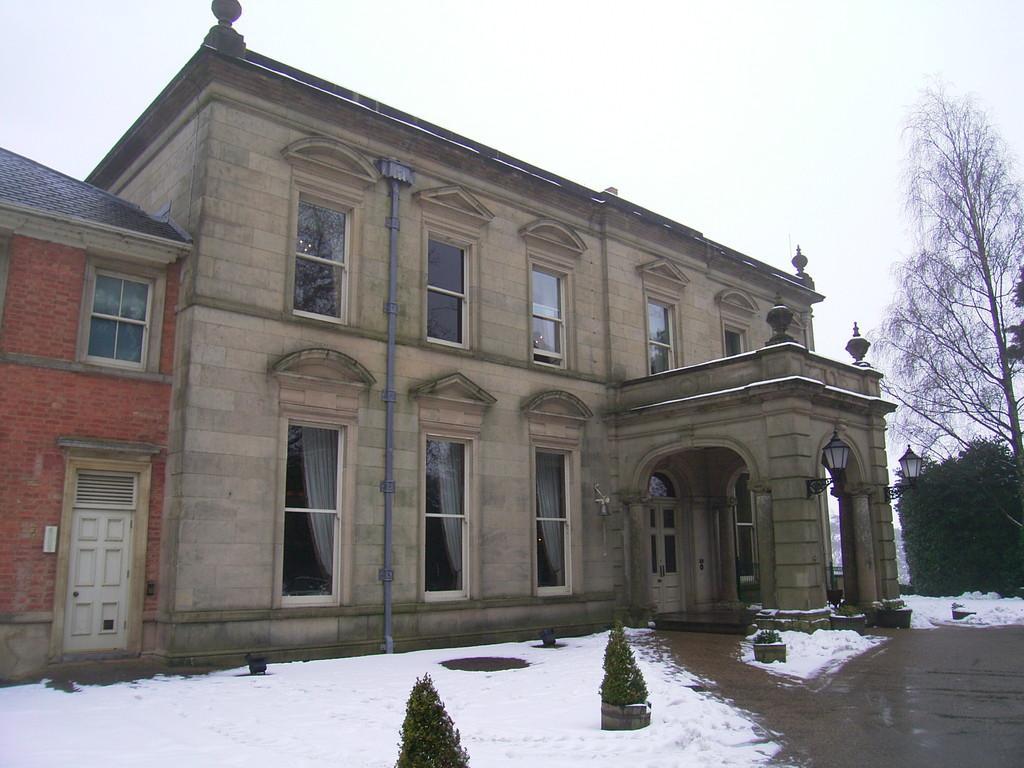Describe this image in one or two sentences. In the image there is a building in the back with many windows and snow,plants in front of it and above its sky. 